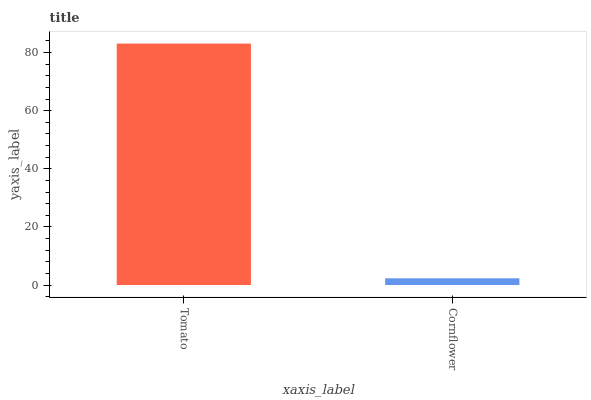Is Cornflower the minimum?
Answer yes or no. Yes. Is Tomato the maximum?
Answer yes or no. Yes. Is Cornflower the maximum?
Answer yes or no. No. Is Tomato greater than Cornflower?
Answer yes or no. Yes. Is Cornflower less than Tomato?
Answer yes or no. Yes. Is Cornflower greater than Tomato?
Answer yes or no. No. Is Tomato less than Cornflower?
Answer yes or no. No. Is Tomato the high median?
Answer yes or no. Yes. Is Cornflower the low median?
Answer yes or no. Yes. Is Cornflower the high median?
Answer yes or no. No. Is Tomato the low median?
Answer yes or no. No. 